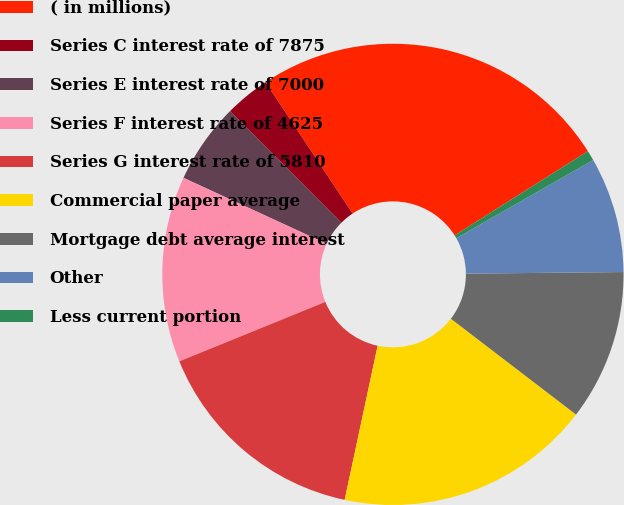Convert chart to OTSL. <chart><loc_0><loc_0><loc_500><loc_500><pie_chart><fcel>( in millions)<fcel>Series C interest rate of 7875<fcel>Series E interest rate of 7000<fcel>Series F interest rate of 4625<fcel>Series G interest rate of 5810<fcel>Commercial paper average<fcel>Mortgage debt average interest<fcel>Other<fcel>Less current portion<nl><fcel>25.35%<fcel>3.17%<fcel>5.64%<fcel>13.03%<fcel>15.49%<fcel>17.96%<fcel>10.56%<fcel>8.1%<fcel>0.71%<nl></chart> 